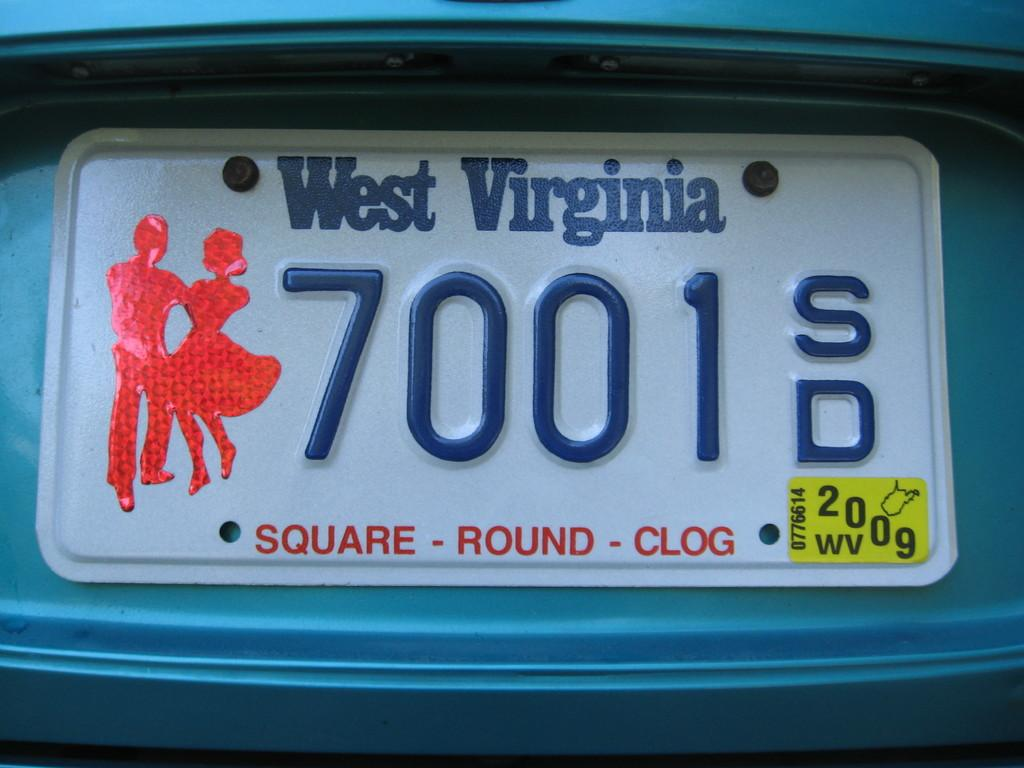<image>
Relay a brief, clear account of the picture shown. A car licenses plate from West Virginia has a sticker of two people clogging. 